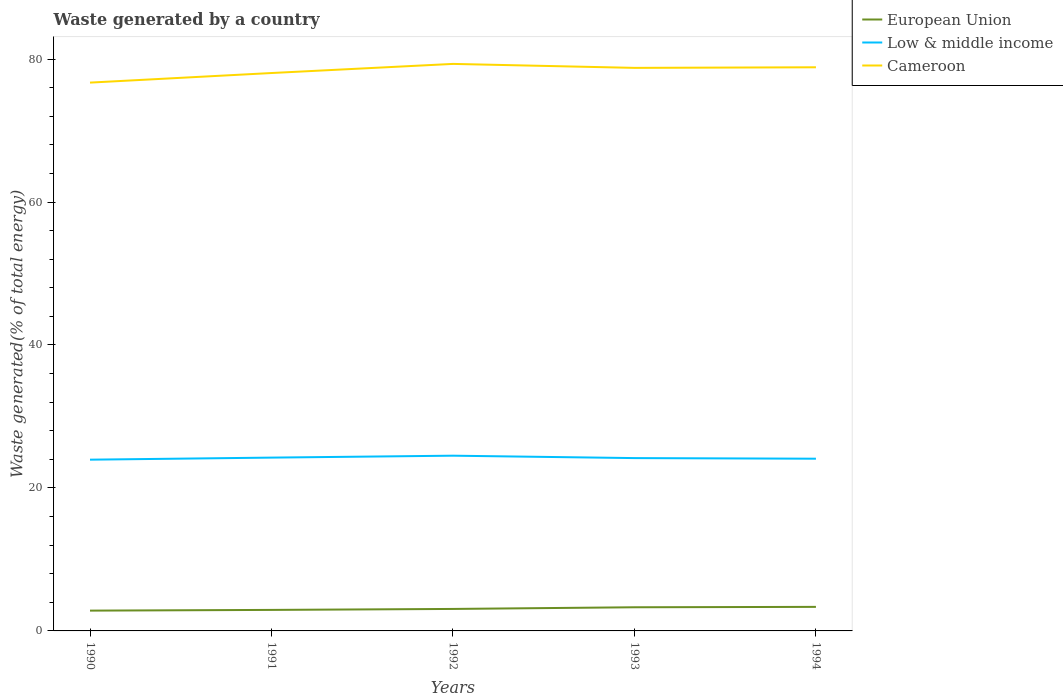How many different coloured lines are there?
Make the answer very short. 3. Does the line corresponding to Cameroon intersect with the line corresponding to European Union?
Give a very brief answer. No. Across all years, what is the maximum total waste generated in Low & middle income?
Provide a short and direct response. 23.95. What is the total total waste generated in Low & middle income in the graph?
Provide a succinct answer. -0.56. What is the difference between the highest and the second highest total waste generated in European Union?
Provide a short and direct response. 0.52. Is the total waste generated in Low & middle income strictly greater than the total waste generated in Cameroon over the years?
Offer a terse response. Yes. Does the graph contain any zero values?
Keep it short and to the point. No. How many legend labels are there?
Your response must be concise. 3. What is the title of the graph?
Your answer should be compact. Waste generated by a country. Does "Lithuania" appear as one of the legend labels in the graph?
Ensure brevity in your answer.  No. What is the label or title of the Y-axis?
Make the answer very short. Waste generated(% of total energy). What is the Waste generated(% of total energy) of European Union in 1990?
Your response must be concise. 2.84. What is the Waste generated(% of total energy) of Low & middle income in 1990?
Keep it short and to the point. 23.95. What is the Waste generated(% of total energy) of Cameroon in 1990?
Your answer should be very brief. 76.7. What is the Waste generated(% of total energy) of European Union in 1991?
Offer a very short reply. 2.94. What is the Waste generated(% of total energy) of Low & middle income in 1991?
Offer a terse response. 24.25. What is the Waste generated(% of total energy) in Cameroon in 1991?
Provide a succinct answer. 78.04. What is the Waste generated(% of total energy) in European Union in 1992?
Make the answer very short. 3.07. What is the Waste generated(% of total energy) of Low & middle income in 1992?
Ensure brevity in your answer.  24.51. What is the Waste generated(% of total energy) in Cameroon in 1992?
Offer a very short reply. 79.32. What is the Waste generated(% of total energy) of European Union in 1993?
Offer a terse response. 3.31. What is the Waste generated(% of total energy) of Low & middle income in 1993?
Offer a very short reply. 24.18. What is the Waste generated(% of total energy) of Cameroon in 1993?
Offer a very short reply. 78.76. What is the Waste generated(% of total energy) of European Union in 1994?
Give a very brief answer. 3.36. What is the Waste generated(% of total energy) of Low & middle income in 1994?
Offer a terse response. 24.09. What is the Waste generated(% of total energy) in Cameroon in 1994?
Provide a short and direct response. 78.85. Across all years, what is the maximum Waste generated(% of total energy) of European Union?
Offer a very short reply. 3.36. Across all years, what is the maximum Waste generated(% of total energy) of Low & middle income?
Ensure brevity in your answer.  24.51. Across all years, what is the maximum Waste generated(% of total energy) in Cameroon?
Make the answer very short. 79.32. Across all years, what is the minimum Waste generated(% of total energy) in European Union?
Make the answer very short. 2.84. Across all years, what is the minimum Waste generated(% of total energy) of Low & middle income?
Keep it short and to the point. 23.95. Across all years, what is the minimum Waste generated(% of total energy) of Cameroon?
Your answer should be very brief. 76.7. What is the total Waste generated(% of total energy) of European Union in the graph?
Provide a short and direct response. 15.53. What is the total Waste generated(% of total energy) of Low & middle income in the graph?
Offer a very short reply. 120.98. What is the total Waste generated(% of total energy) in Cameroon in the graph?
Your answer should be very brief. 391.68. What is the difference between the Waste generated(% of total energy) of European Union in 1990 and that in 1991?
Ensure brevity in your answer.  -0.1. What is the difference between the Waste generated(% of total energy) of Low & middle income in 1990 and that in 1991?
Give a very brief answer. -0.29. What is the difference between the Waste generated(% of total energy) in Cameroon in 1990 and that in 1991?
Give a very brief answer. -1.34. What is the difference between the Waste generated(% of total energy) in European Union in 1990 and that in 1992?
Provide a succinct answer. -0.24. What is the difference between the Waste generated(% of total energy) in Low & middle income in 1990 and that in 1992?
Make the answer very short. -0.56. What is the difference between the Waste generated(% of total energy) in Cameroon in 1990 and that in 1992?
Make the answer very short. -2.62. What is the difference between the Waste generated(% of total energy) in European Union in 1990 and that in 1993?
Offer a terse response. -0.47. What is the difference between the Waste generated(% of total energy) of Low & middle income in 1990 and that in 1993?
Give a very brief answer. -0.22. What is the difference between the Waste generated(% of total energy) in Cameroon in 1990 and that in 1993?
Provide a succinct answer. -2.06. What is the difference between the Waste generated(% of total energy) of European Union in 1990 and that in 1994?
Ensure brevity in your answer.  -0.52. What is the difference between the Waste generated(% of total energy) of Low & middle income in 1990 and that in 1994?
Give a very brief answer. -0.14. What is the difference between the Waste generated(% of total energy) of Cameroon in 1990 and that in 1994?
Provide a short and direct response. -2.14. What is the difference between the Waste generated(% of total energy) in European Union in 1991 and that in 1992?
Offer a very short reply. -0.14. What is the difference between the Waste generated(% of total energy) of Low & middle income in 1991 and that in 1992?
Keep it short and to the point. -0.27. What is the difference between the Waste generated(% of total energy) in Cameroon in 1991 and that in 1992?
Offer a terse response. -1.27. What is the difference between the Waste generated(% of total energy) of European Union in 1991 and that in 1993?
Offer a terse response. -0.37. What is the difference between the Waste generated(% of total energy) of Low & middle income in 1991 and that in 1993?
Your response must be concise. 0.07. What is the difference between the Waste generated(% of total energy) in Cameroon in 1991 and that in 1993?
Provide a short and direct response. -0.72. What is the difference between the Waste generated(% of total energy) of European Union in 1991 and that in 1994?
Keep it short and to the point. -0.42. What is the difference between the Waste generated(% of total energy) of Low & middle income in 1991 and that in 1994?
Provide a short and direct response. 0.15. What is the difference between the Waste generated(% of total energy) of Cameroon in 1991 and that in 1994?
Make the answer very short. -0.8. What is the difference between the Waste generated(% of total energy) in European Union in 1992 and that in 1993?
Make the answer very short. -0.23. What is the difference between the Waste generated(% of total energy) in Low & middle income in 1992 and that in 1993?
Ensure brevity in your answer.  0.34. What is the difference between the Waste generated(% of total energy) of Cameroon in 1992 and that in 1993?
Your answer should be compact. 0.55. What is the difference between the Waste generated(% of total energy) in European Union in 1992 and that in 1994?
Offer a very short reply. -0.29. What is the difference between the Waste generated(% of total energy) of Low & middle income in 1992 and that in 1994?
Provide a short and direct response. 0.42. What is the difference between the Waste generated(% of total energy) in Cameroon in 1992 and that in 1994?
Keep it short and to the point. 0.47. What is the difference between the Waste generated(% of total energy) in European Union in 1993 and that in 1994?
Make the answer very short. -0.06. What is the difference between the Waste generated(% of total energy) of Low & middle income in 1993 and that in 1994?
Offer a terse response. 0.09. What is the difference between the Waste generated(% of total energy) in Cameroon in 1993 and that in 1994?
Provide a short and direct response. -0.08. What is the difference between the Waste generated(% of total energy) of European Union in 1990 and the Waste generated(% of total energy) of Low & middle income in 1991?
Offer a very short reply. -21.41. What is the difference between the Waste generated(% of total energy) of European Union in 1990 and the Waste generated(% of total energy) of Cameroon in 1991?
Offer a very short reply. -75.2. What is the difference between the Waste generated(% of total energy) in Low & middle income in 1990 and the Waste generated(% of total energy) in Cameroon in 1991?
Provide a succinct answer. -54.09. What is the difference between the Waste generated(% of total energy) in European Union in 1990 and the Waste generated(% of total energy) in Low & middle income in 1992?
Your answer should be compact. -21.67. What is the difference between the Waste generated(% of total energy) of European Union in 1990 and the Waste generated(% of total energy) of Cameroon in 1992?
Ensure brevity in your answer.  -76.48. What is the difference between the Waste generated(% of total energy) in Low & middle income in 1990 and the Waste generated(% of total energy) in Cameroon in 1992?
Offer a very short reply. -55.36. What is the difference between the Waste generated(% of total energy) in European Union in 1990 and the Waste generated(% of total energy) in Low & middle income in 1993?
Give a very brief answer. -21.34. What is the difference between the Waste generated(% of total energy) in European Union in 1990 and the Waste generated(% of total energy) in Cameroon in 1993?
Keep it short and to the point. -75.93. What is the difference between the Waste generated(% of total energy) in Low & middle income in 1990 and the Waste generated(% of total energy) in Cameroon in 1993?
Your answer should be very brief. -54.81. What is the difference between the Waste generated(% of total energy) of European Union in 1990 and the Waste generated(% of total energy) of Low & middle income in 1994?
Keep it short and to the point. -21.25. What is the difference between the Waste generated(% of total energy) of European Union in 1990 and the Waste generated(% of total energy) of Cameroon in 1994?
Your answer should be very brief. -76.01. What is the difference between the Waste generated(% of total energy) in Low & middle income in 1990 and the Waste generated(% of total energy) in Cameroon in 1994?
Provide a succinct answer. -54.89. What is the difference between the Waste generated(% of total energy) in European Union in 1991 and the Waste generated(% of total energy) in Low & middle income in 1992?
Offer a very short reply. -21.57. What is the difference between the Waste generated(% of total energy) of European Union in 1991 and the Waste generated(% of total energy) of Cameroon in 1992?
Your answer should be very brief. -76.38. What is the difference between the Waste generated(% of total energy) in Low & middle income in 1991 and the Waste generated(% of total energy) in Cameroon in 1992?
Your answer should be compact. -55.07. What is the difference between the Waste generated(% of total energy) of European Union in 1991 and the Waste generated(% of total energy) of Low & middle income in 1993?
Offer a terse response. -21.24. What is the difference between the Waste generated(% of total energy) in European Union in 1991 and the Waste generated(% of total energy) in Cameroon in 1993?
Your answer should be very brief. -75.82. What is the difference between the Waste generated(% of total energy) in Low & middle income in 1991 and the Waste generated(% of total energy) in Cameroon in 1993?
Provide a succinct answer. -54.52. What is the difference between the Waste generated(% of total energy) in European Union in 1991 and the Waste generated(% of total energy) in Low & middle income in 1994?
Your response must be concise. -21.15. What is the difference between the Waste generated(% of total energy) of European Union in 1991 and the Waste generated(% of total energy) of Cameroon in 1994?
Offer a very short reply. -75.91. What is the difference between the Waste generated(% of total energy) in Low & middle income in 1991 and the Waste generated(% of total energy) in Cameroon in 1994?
Give a very brief answer. -54.6. What is the difference between the Waste generated(% of total energy) of European Union in 1992 and the Waste generated(% of total energy) of Low & middle income in 1993?
Give a very brief answer. -21.1. What is the difference between the Waste generated(% of total energy) of European Union in 1992 and the Waste generated(% of total energy) of Cameroon in 1993?
Ensure brevity in your answer.  -75.69. What is the difference between the Waste generated(% of total energy) of Low & middle income in 1992 and the Waste generated(% of total energy) of Cameroon in 1993?
Provide a short and direct response. -54.25. What is the difference between the Waste generated(% of total energy) of European Union in 1992 and the Waste generated(% of total energy) of Low & middle income in 1994?
Ensure brevity in your answer.  -21.02. What is the difference between the Waste generated(% of total energy) in European Union in 1992 and the Waste generated(% of total energy) in Cameroon in 1994?
Make the answer very short. -75.77. What is the difference between the Waste generated(% of total energy) in Low & middle income in 1992 and the Waste generated(% of total energy) in Cameroon in 1994?
Provide a short and direct response. -54.33. What is the difference between the Waste generated(% of total energy) of European Union in 1993 and the Waste generated(% of total energy) of Low & middle income in 1994?
Your answer should be compact. -20.78. What is the difference between the Waste generated(% of total energy) of European Union in 1993 and the Waste generated(% of total energy) of Cameroon in 1994?
Your response must be concise. -75.54. What is the difference between the Waste generated(% of total energy) of Low & middle income in 1993 and the Waste generated(% of total energy) of Cameroon in 1994?
Ensure brevity in your answer.  -54.67. What is the average Waste generated(% of total energy) of European Union per year?
Offer a very short reply. 3.1. What is the average Waste generated(% of total energy) of Low & middle income per year?
Your response must be concise. 24.2. What is the average Waste generated(% of total energy) of Cameroon per year?
Offer a terse response. 78.34. In the year 1990, what is the difference between the Waste generated(% of total energy) in European Union and Waste generated(% of total energy) in Low & middle income?
Ensure brevity in your answer.  -21.12. In the year 1990, what is the difference between the Waste generated(% of total energy) in European Union and Waste generated(% of total energy) in Cameroon?
Give a very brief answer. -73.86. In the year 1990, what is the difference between the Waste generated(% of total energy) of Low & middle income and Waste generated(% of total energy) of Cameroon?
Provide a short and direct response. -52.75. In the year 1991, what is the difference between the Waste generated(% of total energy) in European Union and Waste generated(% of total energy) in Low & middle income?
Keep it short and to the point. -21.31. In the year 1991, what is the difference between the Waste generated(% of total energy) in European Union and Waste generated(% of total energy) in Cameroon?
Make the answer very short. -75.1. In the year 1991, what is the difference between the Waste generated(% of total energy) of Low & middle income and Waste generated(% of total energy) of Cameroon?
Keep it short and to the point. -53.8. In the year 1992, what is the difference between the Waste generated(% of total energy) of European Union and Waste generated(% of total energy) of Low & middle income?
Make the answer very short. -21.44. In the year 1992, what is the difference between the Waste generated(% of total energy) of European Union and Waste generated(% of total energy) of Cameroon?
Provide a succinct answer. -76.24. In the year 1992, what is the difference between the Waste generated(% of total energy) of Low & middle income and Waste generated(% of total energy) of Cameroon?
Offer a terse response. -54.81. In the year 1993, what is the difference between the Waste generated(% of total energy) in European Union and Waste generated(% of total energy) in Low & middle income?
Provide a succinct answer. -20.87. In the year 1993, what is the difference between the Waste generated(% of total energy) of European Union and Waste generated(% of total energy) of Cameroon?
Provide a short and direct response. -75.46. In the year 1993, what is the difference between the Waste generated(% of total energy) of Low & middle income and Waste generated(% of total energy) of Cameroon?
Provide a short and direct response. -54.59. In the year 1994, what is the difference between the Waste generated(% of total energy) in European Union and Waste generated(% of total energy) in Low & middle income?
Offer a terse response. -20.73. In the year 1994, what is the difference between the Waste generated(% of total energy) in European Union and Waste generated(% of total energy) in Cameroon?
Offer a very short reply. -75.48. In the year 1994, what is the difference between the Waste generated(% of total energy) of Low & middle income and Waste generated(% of total energy) of Cameroon?
Provide a short and direct response. -54.76. What is the ratio of the Waste generated(% of total energy) in European Union in 1990 to that in 1991?
Provide a succinct answer. 0.97. What is the ratio of the Waste generated(% of total energy) of Low & middle income in 1990 to that in 1991?
Offer a terse response. 0.99. What is the ratio of the Waste generated(% of total energy) in Cameroon in 1990 to that in 1991?
Ensure brevity in your answer.  0.98. What is the ratio of the Waste generated(% of total energy) of European Union in 1990 to that in 1992?
Provide a succinct answer. 0.92. What is the ratio of the Waste generated(% of total energy) of Low & middle income in 1990 to that in 1992?
Offer a very short reply. 0.98. What is the ratio of the Waste generated(% of total energy) in European Union in 1990 to that in 1993?
Provide a short and direct response. 0.86. What is the ratio of the Waste generated(% of total energy) in Low & middle income in 1990 to that in 1993?
Your answer should be compact. 0.99. What is the ratio of the Waste generated(% of total energy) of Cameroon in 1990 to that in 1993?
Keep it short and to the point. 0.97. What is the ratio of the Waste generated(% of total energy) in European Union in 1990 to that in 1994?
Keep it short and to the point. 0.84. What is the ratio of the Waste generated(% of total energy) in Low & middle income in 1990 to that in 1994?
Ensure brevity in your answer.  0.99. What is the ratio of the Waste generated(% of total energy) of Cameroon in 1990 to that in 1994?
Ensure brevity in your answer.  0.97. What is the ratio of the Waste generated(% of total energy) of European Union in 1991 to that in 1992?
Your response must be concise. 0.96. What is the ratio of the Waste generated(% of total energy) in Cameroon in 1991 to that in 1992?
Provide a short and direct response. 0.98. What is the ratio of the Waste generated(% of total energy) of European Union in 1991 to that in 1993?
Offer a very short reply. 0.89. What is the ratio of the Waste generated(% of total energy) of Cameroon in 1991 to that in 1993?
Keep it short and to the point. 0.99. What is the ratio of the Waste generated(% of total energy) of European Union in 1991 to that in 1994?
Provide a short and direct response. 0.87. What is the ratio of the Waste generated(% of total energy) in Low & middle income in 1991 to that in 1994?
Your answer should be compact. 1.01. What is the ratio of the Waste generated(% of total energy) of European Union in 1992 to that in 1993?
Your response must be concise. 0.93. What is the ratio of the Waste generated(% of total energy) of Low & middle income in 1992 to that in 1993?
Keep it short and to the point. 1.01. What is the ratio of the Waste generated(% of total energy) in European Union in 1992 to that in 1994?
Keep it short and to the point. 0.91. What is the ratio of the Waste generated(% of total energy) of Low & middle income in 1992 to that in 1994?
Ensure brevity in your answer.  1.02. What is the ratio of the Waste generated(% of total energy) in European Union in 1993 to that in 1994?
Provide a short and direct response. 0.98. What is the difference between the highest and the second highest Waste generated(% of total energy) of European Union?
Your response must be concise. 0.06. What is the difference between the highest and the second highest Waste generated(% of total energy) of Low & middle income?
Keep it short and to the point. 0.27. What is the difference between the highest and the second highest Waste generated(% of total energy) in Cameroon?
Your answer should be compact. 0.47. What is the difference between the highest and the lowest Waste generated(% of total energy) in European Union?
Ensure brevity in your answer.  0.52. What is the difference between the highest and the lowest Waste generated(% of total energy) of Low & middle income?
Provide a short and direct response. 0.56. What is the difference between the highest and the lowest Waste generated(% of total energy) of Cameroon?
Your answer should be very brief. 2.62. 